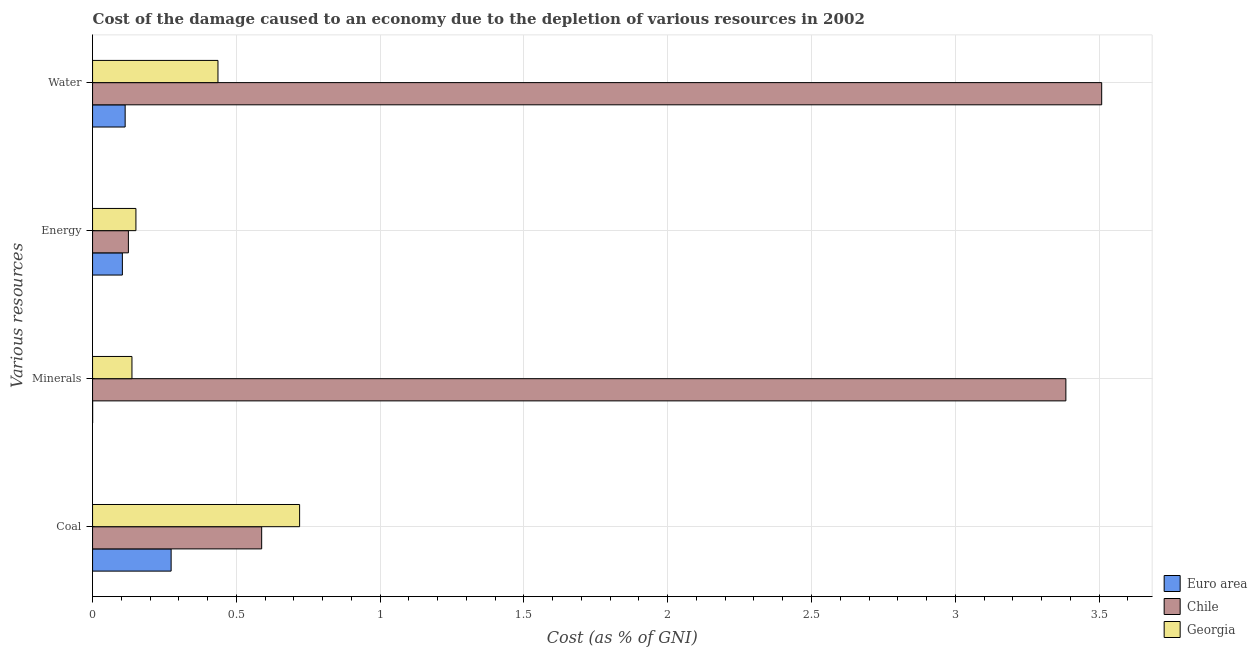How many bars are there on the 3rd tick from the bottom?
Keep it short and to the point. 3. What is the label of the 3rd group of bars from the top?
Your answer should be compact. Minerals. What is the cost of damage due to depletion of energy in Euro area?
Provide a succinct answer. 0.1. Across all countries, what is the maximum cost of damage due to depletion of water?
Your answer should be compact. 3.51. Across all countries, what is the minimum cost of damage due to depletion of coal?
Your answer should be compact. 0.27. In which country was the cost of damage due to depletion of minerals minimum?
Give a very brief answer. Euro area. What is the total cost of damage due to depletion of minerals in the graph?
Your response must be concise. 3.52. What is the difference between the cost of damage due to depletion of water in Euro area and that in Georgia?
Your answer should be very brief. -0.32. What is the difference between the cost of damage due to depletion of energy in Euro area and the cost of damage due to depletion of coal in Georgia?
Provide a succinct answer. -0.62. What is the average cost of damage due to depletion of water per country?
Offer a very short reply. 1.35. What is the difference between the cost of damage due to depletion of water and cost of damage due to depletion of minerals in Chile?
Ensure brevity in your answer.  0.12. What is the ratio of the cost of damage due to depletion of energy in Georgia to that in Euro area?
Provide a short and direct response. 1.45. What is the difference between the highest and the second highest cost of damage due to depletion of minerals?
Make the answer very short. 3.25. What is the difference between the highest and the lowest cost of damage due to depletion of energy?
Give a very brief answer. 0.05. In how many countries, is the cost of damage due to depletion of energy greater than the average cost of damage due to depletion of energy taken over all countries?
Ensure brevity in your answer.  1. Is it the case that in every country, the sum of the cost of damage due to depletion of minerals and cost of damage due to depletion of water is greater than the sum of cost of damage due to depletion of coal and cost of damage due to depletion of energy?
Your answer should be very brief. No. What does the 2nd bar from the top in Minerals represents?
Ensure brevity in your answer.  Chile. What does the 3rd bar from the bottom in Water represents?
Give a very brief answer. Georgia. Is it the case that in every country, the sum of the cost of damage due to depletion of coal and cost of damage due to depletion of minerals is greater than the cost of damage due to depletion of energy?
Your response must be concise. Yes. Are the values on the major ticks of X-axis written in scientific E-notation?
Give a very brief answer. No. Does the graph contain grids?
Offer a terse response. Yes. Where does the legend appear in the graph?
Offer a terse response. Bottom right. What is the title of the graph?
Provide a short and direct response. Cost of the damage caused to an economy due to the depletion of various resources in 2002 . What is the label or title of the X-axis?
Give a very brief answer. Cost (as % of GNI). What is the label or title of the Y-axis?
Your answer should be very brief. Various resources. What is the Cost (as % of GNI) of Euro area in Coal?
Your answer should be compact. 0.27. What is the Cost (as % of GNI) of Chile in Coal?
Ensure brevity in your answer.  0.59. What is the Cost (as % of GNI) in Georgia in Coal?
Your answer should be very brief. 0.72. What is the Cost (as % of GNI) in Euro area in Minerals?
Provide a succinct answer. 0. What is the Cost (as % of GNI) in Chile in Minerals?
Make the answer very short. 3.38. What is the Cost (as % of GNI) of Georgia in Minerals?
Provide a succinct answer. 0.14. What is the Cost (as % of GNI) of Euro area in Energy?
Offer a terse response. 0.1. What is the Cost (as % of GNI) of Chile in Energy?
Ensure brevity in your answer.  0.12. What is the Cost (as % of GNI) in Georgia in Energy?
Provide a succinct answer. 0.15. What is the Cost (as % of GNI) in Euro area in Water?
Ensure brevity in your answer.  0.11. What is the Cost (as % of GNI) of Chile in Water?
Your answer should be very brief. 3.51. What is the Cost (as % of GNI) in Georgia in Water?
Keep it short and to the point. 0.44. Across all Various resources, what is the maximum Cost (as % of GNI) in Euro area?
Your answer should be very brief. 0.27. Across all Various resources, what is the maximum Cost (as % of GNI) of Chile?
Provide a short and direct response. 3.51. Across all Various resources, what is the maximum Cost (as % of GNI) in Georgia?
Make the answer very short. 0.72. Across all Various resources, what is the minimum Cost (as % of GNI) of Euro area?
Offer a terse response. 0. Across all Various resources, what is the minimum Cost (as % of GNI) in Chile?
Ensure brevity in your answer.  0.12. Across all Various resources, what is the minimum Cost (as % of GNI) in Georgia?
Give a very brief answer. 0.14. What is the total Cost (as % of GNI) of Euro area in the graph?
Give a very brief answer. 0.49. What is the total Cost (as % of GNI) in Chile in the graph?
Keep it short and to the point. 7.61. What is the total Cost (as % of GNI) in Georgia in the graph?
Make the answer very short. 1.44. What is the difference between the Cost (as % of GNI) of Euro area in Coal and that in Minerals?
Your response must be concise. 0.27. What is the difference between the Cost (as % of GNI) in Chile in Coal and that in Minerals?
Provide a succinct answer. -2.8. What is the difference between the Cost (as % of GNI) in Georgia in Coal and that in Minerals?
Your answer should be compact. 0.58. What is the difference between the Cost (as % of GNI) in Euro area in Coal and that in Energy?
Keep it short and to the point. 0.17. What is the difference between the Cost (as % of GNI) of Chile in Coal and that in Energy?
Provide a short and direct response. 0.46. What is the difference between the Cost (as % of GNI) of Georgia in Coal and that in Energy?
Provide a succinct answer. 0.57. What is the difference between the Cost (as % of GNI) of Euro area in Coal and that in Water?
Provide a succinct answer. 0.16. What is the difference between the Cost (as % of GNI) of Chile in Coal and that in Water?
Provide a short and direct response. -2.92. What is the difference between the Cost (as % of GNI) of Georgia in Coal and that in Water?
Offer a terse response. 0.28. What is the difference between the Cost (as % of GNI) in Euro area in Minerals and that in Energy?
Give a very brief answer. -0.1. What is the difference between the Cost (as % of GNI) of Chile in Minerals and that in Energy?
Ensure brevity in your answer.  3.26. What is the difference between the Cost (as % of GNI) in Georgia in Minerals and that in Energy?
Your answer should be very brief. -0.01. What is the difference between the Cost (as % of GNI) of Euro area in Minerals and that in Water?
Offer a very short reply. -0.11. What is the difference between the Cost (as % of GNI) of Chile in Minerals and that in Water?
Keep it short and to the point. -0.12. What is the difference between the Cost (as % of GNI) of Georgia in Minerals and that in Water?
Your answer should be very brief. -0.3. What is the difference between the Cost (as % of GNI) of Euro area in Energy and that in Water?
Provide a short and direct response. -0.01. What is the difference between the Cost (as % of GNI) of Chile in Energy and that in Water?
Keep it short and to the point. -3.38. What is the difference between the Cost (as % of GNI) of Georgia in Energy and that in Water?
Give a very brief answer. -0.29. What is the difference between the Cost (as % of GNI) in Euro area in Coal and the Cost (as % of GNI) in Chile in Minerals?
Ensure brevity in your answer.  -3.11. What is the difference between the Cost (as % of GNI) in Euro area in Coal and the Cost (as % of GNI) in Georgia in Minerals?
Offer a terse response. 0.14. What is the difference between the Cost (as % of GNI) of Chile in Coal and the Cost (as % of GNI) of Georgia in Minerals?
Provide a short and direct response. 0.45. What is the difference between the Cost (as % of GNI) in Euro area in Coal and the Cost (as % of GNI) in Chile in Energy?
Give a very brief answer. 0.15. What is the difference between the Cost (as % of GNI) in Euro area in Coal and the Cost (as % of GNI) in Georgia in Energy?
Provide a short and direct response. 0.12. What is the difference between the Cost (as % of GNI) of Chile in Coal and the Cost (as % of GNI) of Georgia in Energy?
Your response must be concise. 0.44. What is the difference between the Cost (as % of GNI) of Euro area in Coal and the Cost (as % of GNI) of Chile in Water?
Your answer should be very brief. -3.24. What is the difference between the Cost (as % of GNI) in Euro area in Coal and the Cost (as % of GNI) in Georgia in Water?
Keep it short and to the point. -0.16. What is the difference between the Cost (as % of GNI) in Chile in Coal and the Cost (as % of GNI) in Georgia in Water?
Offer a terse response. 0.15. What is the difference between the Cost (as % of GNI) of Euro area in Minerals and the Cost (as % of GNI) of Chile in Energy?
Provide a succinct answer. -0.12. What is the difference between the Cost (as % of GNI) in Euro area in Minerals and the Cost (as % of GNI) in Georgia in Energy?
Keep it short and to the point. -0.15. What is the difference between the Cost (as % of GNI) of Chile in Minerals and the Cost (as % of GNI) of Georgia in Energy?
Give a very brief answer. 3.23. What is the difference between the Cost (as % of GNI) in Euro area in Minerals and the Cost (as % of GNI) in Chile in Water?
Offer a very short reply. -3.51. What is the difference between the Cost (as % of GNI) in Euro area in Minerals and the Cost (as % of GNI) in Georgia in Water?
Provide a short and direct response. -0.44. What is the difference between the Cost (as % of GNI) of Chile in Minerals and the Cost (as % of GNI) of Georgia in Water?
Provide a succinct answer. 2.95. What is the difference between the Cost (as % of GNI) in Euro area in Energy and the Cost (as % of GNI) in Chile in Water?
Ensure brevity in your answer.  -3.41. What is the difference between the Cost (as % of GNI) in Euro area in Energy and the Cost (as % of GNI) in Georgia in Water?
Keep it short and to the point. -0.33. What is the difference between the Cost (as % of GNI) in Chile in Energy and the Cost (as % of GNI) in Georgia in Water?
Make the answer very short. -0.31. What is the average Cost (as % of GNI) in Euro area per Various resources?
Your answer should be very brief. 0.12. What is the average Cost (as % of GNI) in Chile per Various resources?
Keep it short and to the point. 1.9. What is the average Cost (as % of GNI) in Georgia per Various resources?
Keep it short and to the point. 0.36. What is the difference between the Cost (as % of GNI) in Euro area and Cost (as % of GNI) in Chile in Coal?
Give a very brief answer. -0.31. What is the difference between the Cost (as % of GNI) of Euro area and Cost (as % of GNI) of Georgia in Coal?
Your answer should be compact. -0.45. What is the difference between the Cost (as % of GNI) in Chile and Cost (as % of GNI) in Georgia in Coal?
Give a very brief answer. -0.13. What is the difference between the Cost (as % of GNI) in Euro area and Cost (as % of GNI) in Chile in Minerals?
Your answer should be compact. -3.38. What is the difference between the Cost (as % of GNI) in Euro area and Cost (as % of GNI) in Georgia in Minerals?
Provide a succinct answer. -0.14. What is the difference between the Cost (as % of GNI) in Chile and Cost (as % of GNI) in Georgia in Minerals?
Your answer should be very brief. 3.25. What is the difference between the Cost (as % of GNI) in Euro area and Cost (as % of GNI) in Chile in Energy?
Offer a very short reply. -0.02. What is the difference between the Cost (as % of GNI) in Euro area and Cost (as % of GNI) in Georgia in Energy?
Your response must be concise. -0.05. What is the difference between the Cost (as % of GNI) of Chile and Cost (as % of GNI) of Georgia in Energy?
Your response must be concise. -0.03. What is the difference between the Cost (as % of GNI) in Euro area and Cost (as % of GNI) in Chile in Water?
Your answer should be very brief. -3.4. What is the difference between the Cost (as % of GNI) of Euro area and Cost (as % of GNI) of Georgia in Water?
Your answer should be compact. -0.32. What is the difference between the Cost (as % of GNI) of Chile and Cost (as % of GNI) of Georgia in Water?
Offer a very short reply. 3.07. What is the ratio of the Cost (as % of GNI) in Euro area in Coal to that in Minerals?
Your answer should be compact. 1127.12. What is the ratio of the Cost (as % of GNI) in Chile in Coal to that in Minerals?
Your answer should be compact. 0.17. What is the ratio of the Cost (as % of GNI) in Georgia in Coal to that in Minerals?
Offer a terse response. 5.26. What is the ratio of the Cost (as % of GNI) of Euro area in Coal to that in Energy?
Your answer should be very brief. 2.63. What is the ratio of the Cost (as % of GNI) in Chile in Coal to that in Energy?
Keep it short and to the point. 4.72. What is the ratio of the Cost (as % of GNI) in Georgia in Coal to that in Energy?
Your response must be concise. 4.78. What is the ratio of the Cost (as % of GNI) in Euro area in Coal to that in Water?
Offer a very short reply. 2.41. What is the ratio of the Cost (as % of GNI) in Chile in Coal to that in Water?
Give a very brief answer. 0.17. What is the ratio of the Cost (as % of GNI) in Georgia in Coal to that in Water?
Offer a very short reply. 1.65. What is the ratio of the Cost (as % of GNI) in Euro area in Minerals to that in Energy?
Make the answer very short. 0. What is the ratio of the Cost (as % of GNI) of Chile in Minerals to that in Energy?
Ensure brevity in your answer.  27.17. What is the ratio of the Cost (as % of GNI) in Georgia in Minerals to that in Energy?
Make the answer very short. 0.91. What is the ratio of the Cost (as % of GNI) of Euro area in Minerals to that in Water?
Your answer should be compact. 0. What is the ratio of the Cost (as % of GNI) of Chile in Minerals to that in Water?
Ensure brevity in your answer.  0.96. What is the ratio of the Cost (as % of GNI) of Georgia in Minerals to that in Water?
Your answer should be compact. 0.31. What is the ratio of the Cost (as % of GNI) of Euro area in Energy to that in Water?
Keep it short and to the point. 0.91. What is the ratio of the Cost (as % of GNI) of Chile in Energy to that in Water?
Keep it short and to the point. 0.04. What is the ratio of the Cost (as % of GNI) of Georgia in Energy to that in Water?
Your response must be concise. 0.35. What is the difference between the highest and the second highest Cost (as % of GNI) in Euro area?
Provide a short and direct response. 0.16. What is the difference between the highest and the second highest Cost (as % of GNI) in Chile?
Provide a succinct answer. 0.12. What is the difference between the highest and the second highest Cost (as % of GNI) of Georgia?
Provide a succinct answer. 0.28. What is the difference between the highest and the lowest Cost (as % of GNI) of Euro area?
Provide a short and direct response. 0.27. What is the difference between the highest and the lowest Cost (as % of GNI) in Chile?
Give a very brief answer. 3.38. What is the difference between the highest and the lowest Cost (as % of GNI) in Georgia?
Your answer should be very brief. 0.58. 